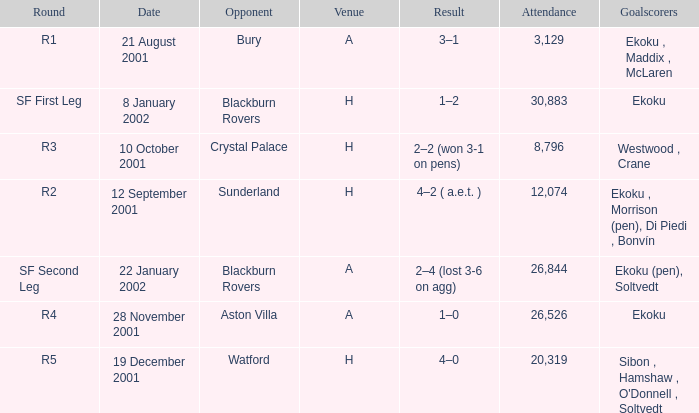Would you mind parsing the complete table? {'header': ['Round', 'Date', 'Opponent', 'Venue', 'Result', 'Attendance', 'Goalscorers'], 'rows': [['R1', '21 August 2001', 'Bury', 'A', '3–1', '3,129', 'Ekoku , Maddix , McLaren'], ['SF First Leg', '8 January 2002', 'Blackburn Rovers', 'H', '1–2', '30,883', 'Ekoku'], ['R3', '10 October 2001', 'Crystal Palace', 'H', '2–2 (won 3-1 on pens)', '8,796', 'Westwood , Crane'], ['R2', '12 September 2001', 'Sunderland', 'H', '4–2 ( a.e.t. )', '12,074', 'Ekoku , Morrison (pen), Di Piedi , Bonvín'], ['SF Second Leg', '22 January 2002', 'Blackburn Rovers', 'A', '2–4 (lost 3-6 on agg)', '26,844', 'Ekoku (pen), Soltvedt'], ['R4', '28 November 2001', 'Aston Villa', 'A', '1–0', '26,526', 'Ekoku'], ['R5', '19 December 2001', 'Watford', 'H', '4–0', '20,319', "Sibon , Hamshaw , O'Donnell , Soltvedt"]]} Which result has sunderland as opponent? 4–2 ( a.e.t. ). 